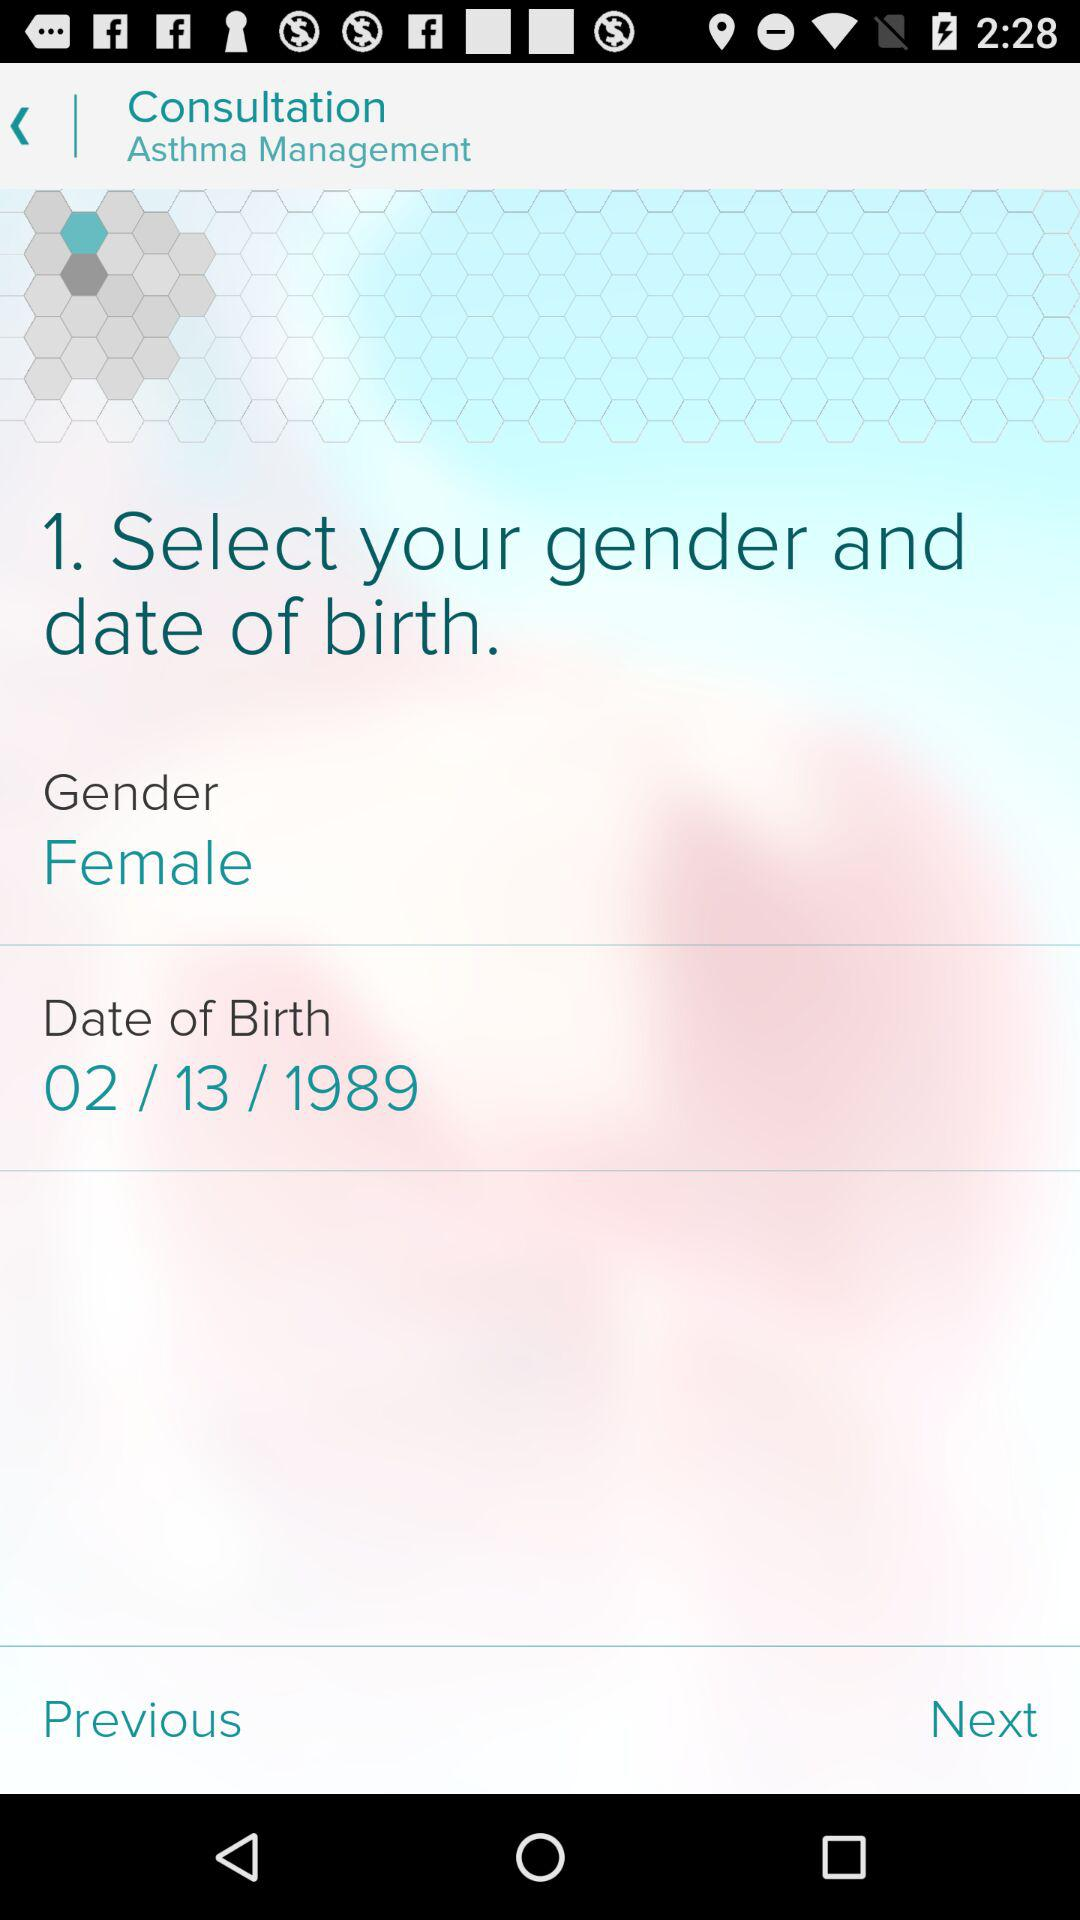What is the date of birth? The date of birth is February 13, 1989. 